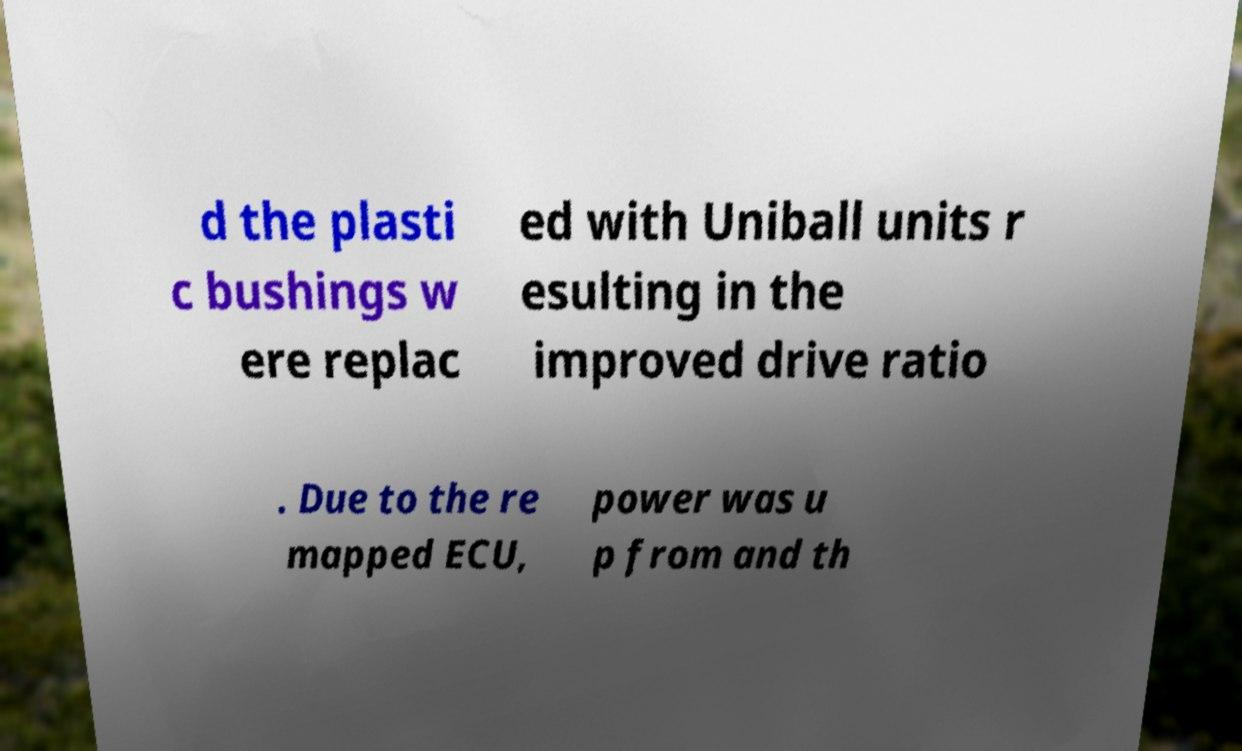Can you accurately transcribe the text from the provided image for me? d the plasti c bushings w ere replac ed with Uniball units r esulting in the improved drive ratio . Due to the re mapped ECU, power was u p from and th 